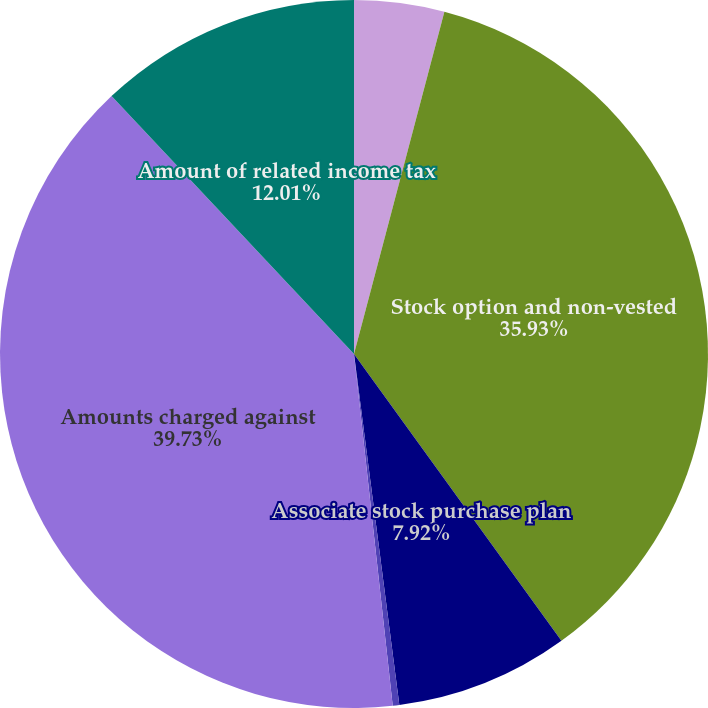<chart> <loc_0><loc_0><loc_500><loc_500><pie_chart><fcel>(In thousands)<fcel>Stock option and non-vested<fcel>Associate stock purchase plan<fcel>Amounts capitalized in<fcel>Amounts charged against<fcel>Amount of related income tax<nl><fcel>4.11%<fcel>35.93%<fcel>7.92%<fcel>0.3%<fcel>39.74%<fcel>12.01%<nl></chart> 